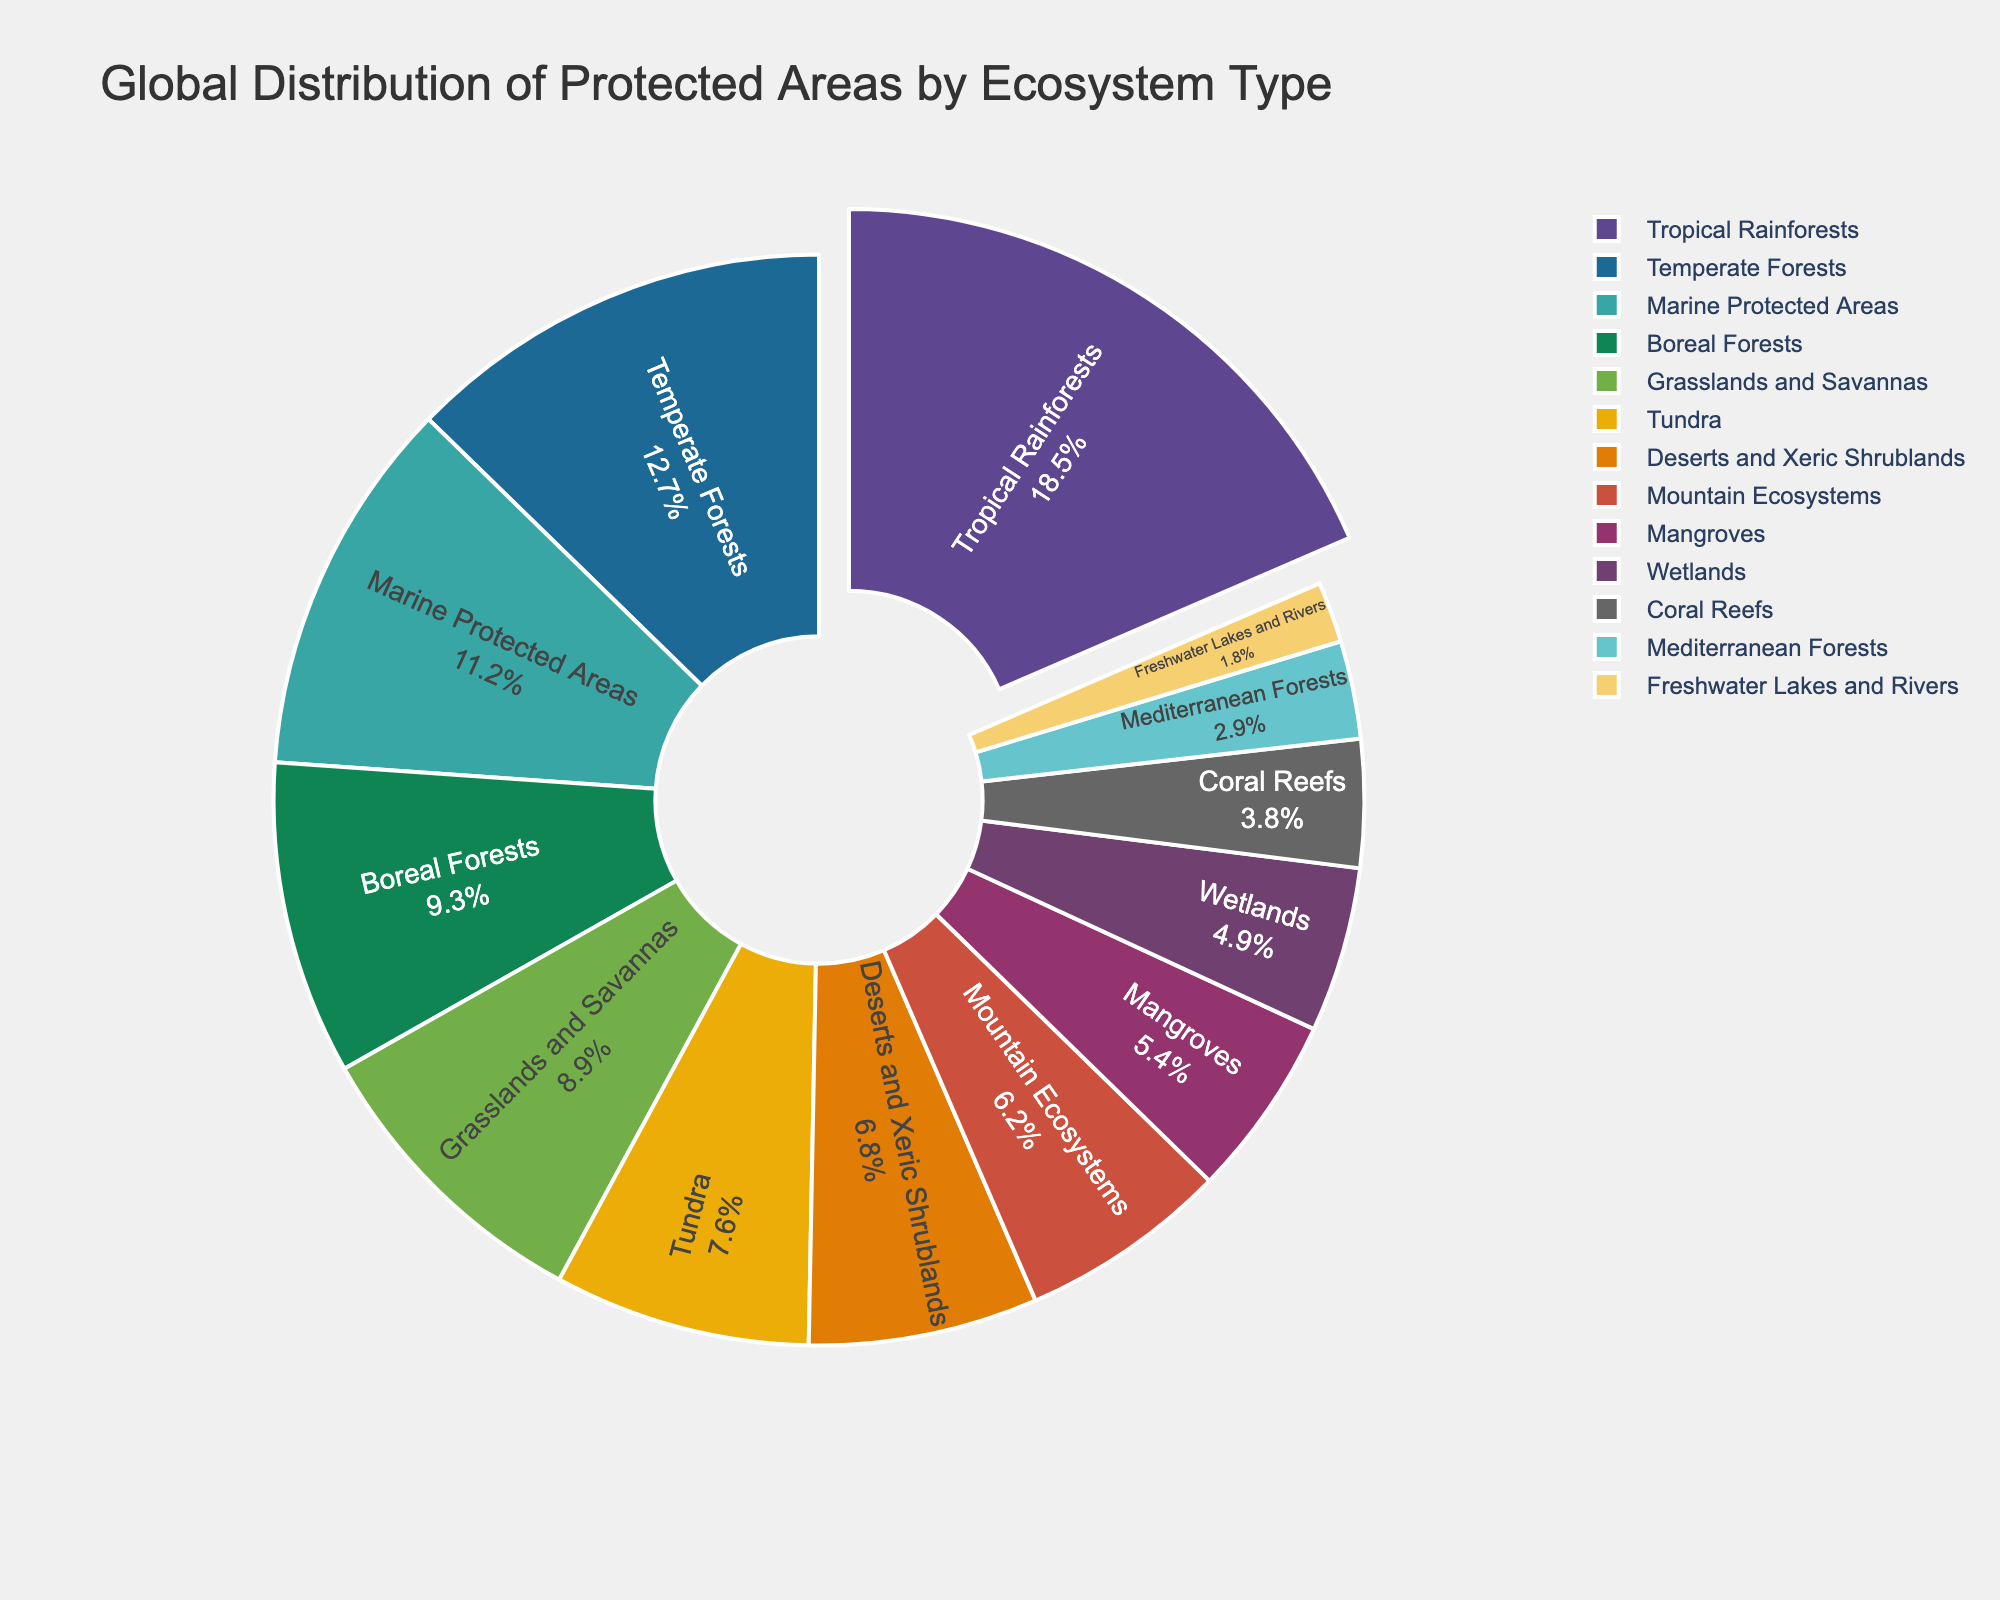What's the largest ecosystem type by percentage in the chart? The largest ecosystem type can be identified by looking at the pie section that is pulled out and having the largest numerical value associated with it. In this case, "Tropical Rainforests" has the highest percentage at 18.5%.
Answer: Tropical Rainforests Which ecosystem type has a smaller percentage: Deserts and Xeric Shrublands or Coral Reefs? By comparing the values provided, Deserts and Xeric Shrublands have a percentage of 6.8%, while Coral Reefs have a percentage of 3.8%. Therefore, Coral Reefs have a smaller percentage.
Answer: Coral Reefs What is the combined percentage of Marine Protected Areas and Mangroves? First, identify the percentages for Marine Protected Areas (11.2%) and Mangroves (5.4%). Then, add these two values together: 11.2% + 5.4% = 16.6%.
Answer: 16.6% How many ecosystem types have a percentage greater than 10%? By scanning the pie chart, we observe that Tropical Rainforests (18.5%), Temperate Forests (12.7%), and Marine Protected Areas (11.2%) are the only types with a percentage greater than 10%. This results in three ecosystem types.
Answer: 3 What is the percentage difference between Boreal Forests and Mountain Ecosystems? Locate the percentages for Boreal Forests (9.3%) and Mountain Ecosystems (6.2%). Then, subtract the smaller percentage from the larger one: 9.3% - 6.2% = 3.1%.
Answer: 3.1% What's the total percentage for forest-related ecosystem types (Tropical Rainforests, Temperate Forests, Boreal Forests, Mediterranean Forests)? Add the percentages for Tropical Rainforests (18.5%), Temperate Forests (12.7%), Boreal Forests (9.3%), and Mediterranean Forests (2.9%): 18.5% + 12.7% + 9.3% + 2.9% = 43.4%.
Answer: 43.4% Which ecosystem type is represented with the color blue? To determine this, identify the color associated with each pie section. The color blue represents the "Marine Protected Areas".
Answer: Marine Protected Areas What is the difference in the combined percentage of Grasslands and Savannas and Tundra compared to the Coral Reefs percentage? First, calculate the combined percentage for Grasslands and Savannas (8.9%) and Tundra (7.6%): 8.9% + 7.6% = 16.5%. Then, subtract the Coral Reefs percentage (3.8%) from this combined percentage: 16.5% - 3.8% = 12.7%.
Answer: 12.7% 